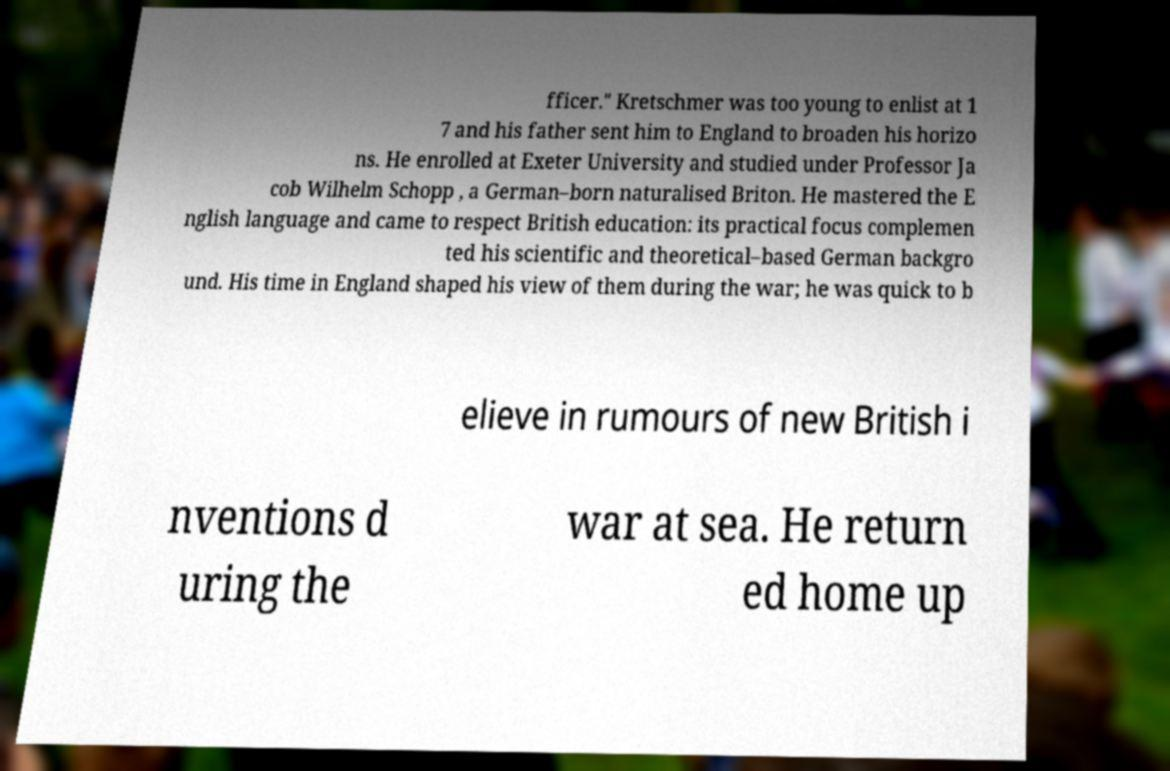Please identify and transcribe the text found in this image. fficer." Kretschmer was too young to enlist at 1 7 and his father sent him to England to broaden his horizo ns. He enrolled at Exeter University and studied under Professor Ja cob Wilhelm Schopp , a German–born naturalised Briton. He mastered the E nglish language and came to respect British education: its practical focus complemen ted his scientific and theoretical–based German backgro und. His time in England shaped his view of them during the war; he was quick to b elieve in rumours of new British i nventions d uring the war at sea. He return ed home up 